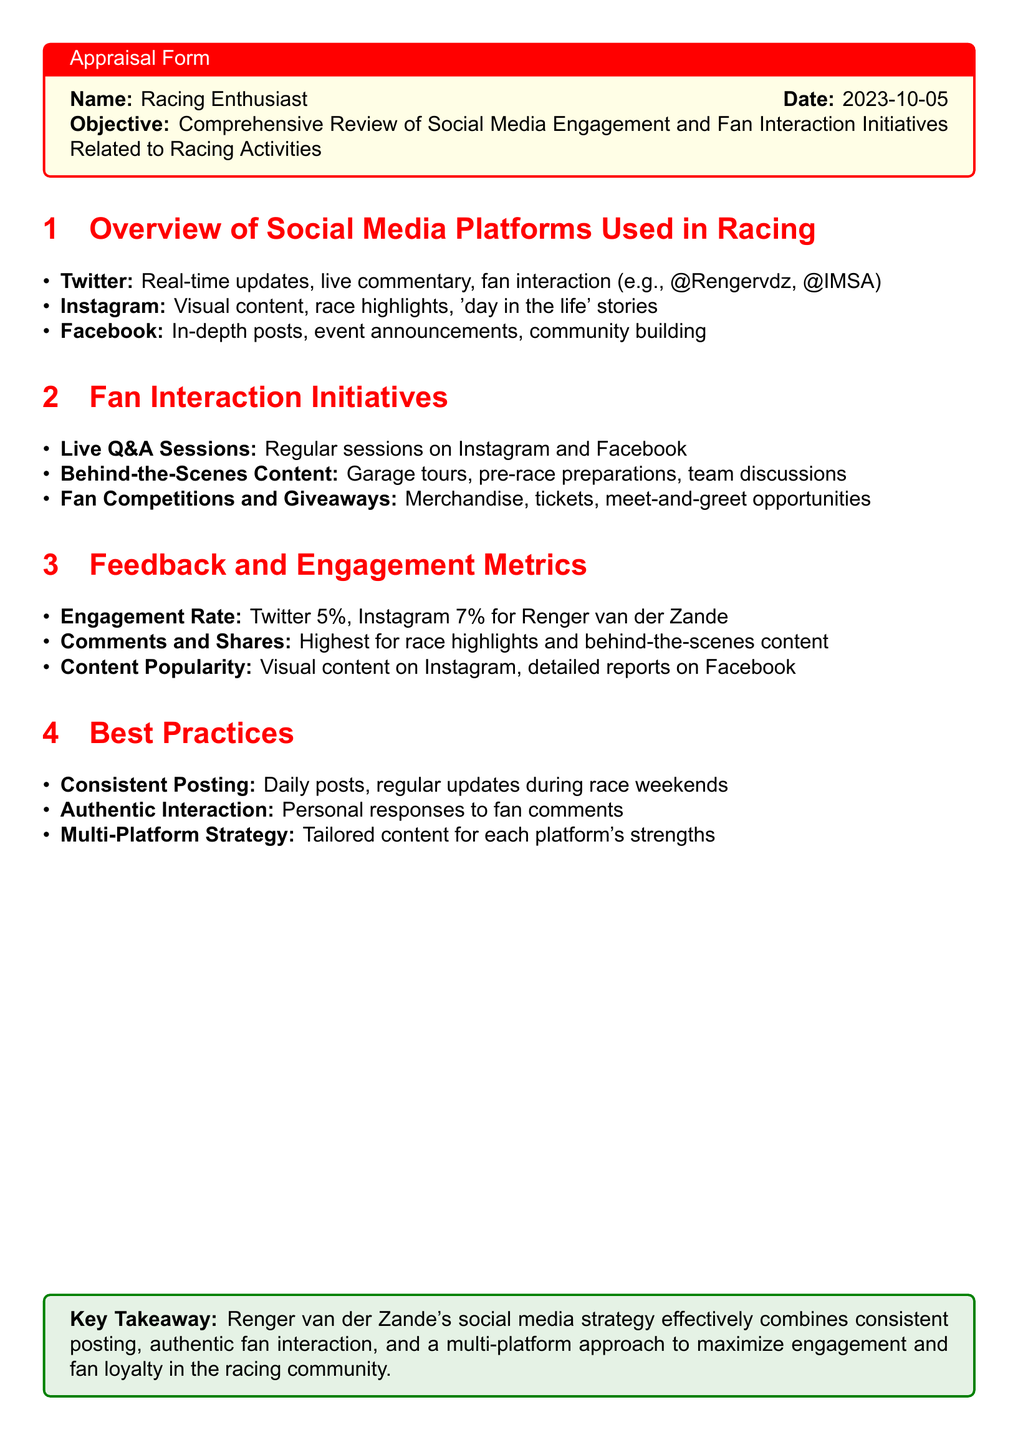What is the date of the appraisal? The date of the appraisal is provided in the header of the document.
Answer: 2023-10-05 What social media platform has a 7% engagement rate for Renger van der Zande? The engagement rates for Renger van der Zande on different platforms are listed in the feedback section.
Answer: Instagram What type of content is most popular on Facebook? The document specifies content popularity based on audience engagement.
Answer: Detailed reports What is a key initiative for fan interaction mentioned in the document? The document lists specific fan interaction initiatives to enhance engagement.
Answer: Live Q&A Sessions What color is used for the title format in the "Overview of Social Media Platforms Used in Racing"? The section title format uses a specific color style which is defined at the beginning of the document.
Answer: Racing red What is one best practice for social media engagement mentioned? The document outlines effective best practices for social media strategies in racing.
Answer: Consistent Posting Which platforms are mentioned for behind-the-scenes content? The initiatives list specifies which platforms are used for sharing behind-the-scenes content.
Answer: Instagram and Facebook What is the key takeaway from the appraisal? The key takeaway summarizes the effectiveness of Renger van der Zande's social media strategy.
Answer: Renger van der Zande's social media strategy effectively combines consistent posting, authentic fan interaction, and a multi-platform approach 